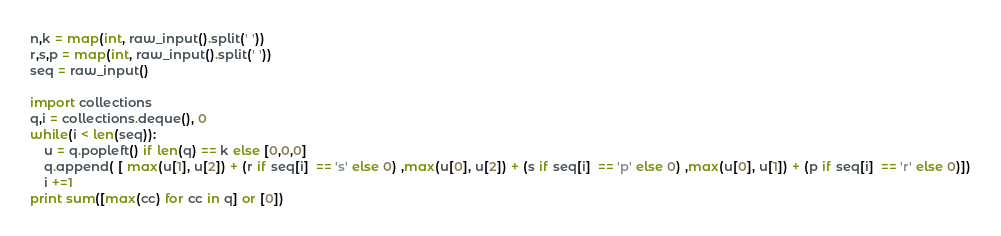Convert code to text. <code><loc_0><loc_0><loc_500><loc_500><_Python_>n,k = map(int, raw_input().split(' '))
r,s,p = map(int, raw_input().split(' '))
seq = raw_input()

import collections
q,i = collections.deque(), 0
while(i < len(seq)):
	u = q.popleft() if len(q) == k else [0,0,0]
	q.append( [ max(u[1], u[2]) + (r if seq[i]  == 's' else 0) ,max(u[0], u[2]) + (s if seq[i]  == 'p' else 0) ,max(u[0], u[1]) + (p if seq[i]  == 'r' else 0)])
	i +=1
print sum([max(cc) for cc in q] or [0])
</code> 